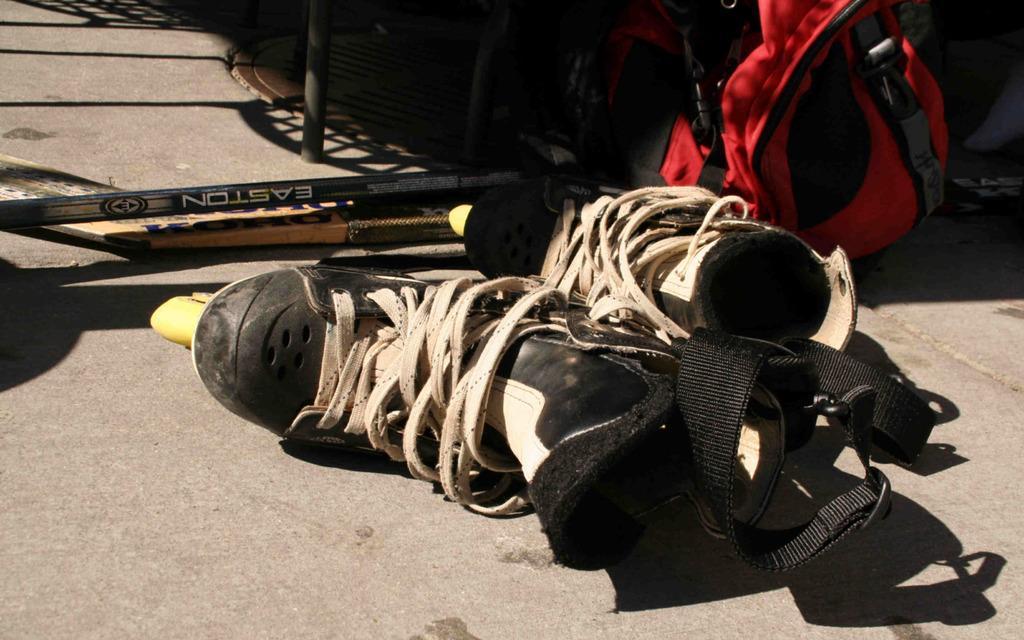How would you summarize this image in a sentence or two? In this image we can see there is a pair of shoes, bag and some other objects on the road. 